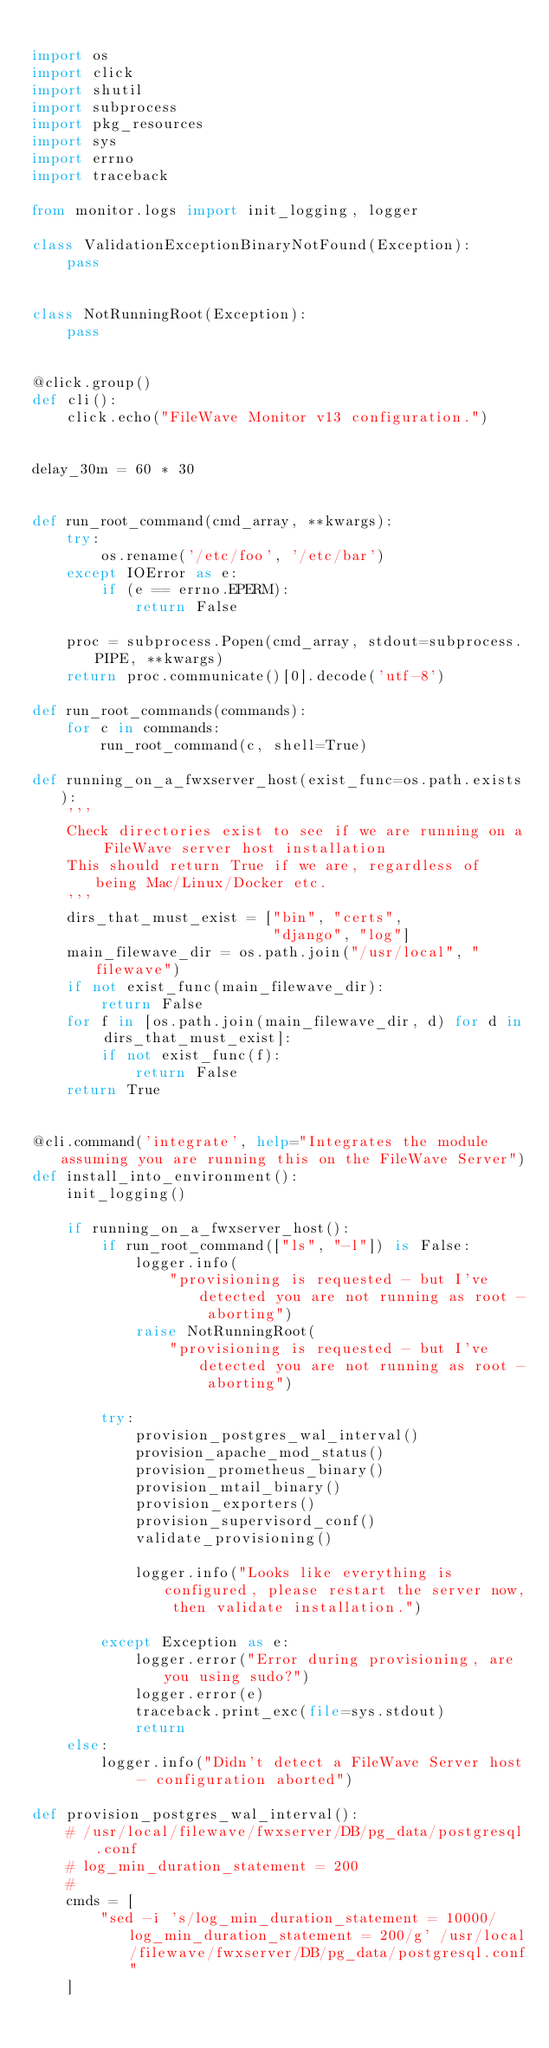<code> <loc_0><loc_0><loc_500><loc_500><_Python_>
import os
import click
import shutil
import subprocess
import pkg_resources
import sys
import errno
import traceback

from monitor.logs import init_logging, logger

class ValidationExceptionBinaryNotFound(Exception):
    pass


class NotRunningRoot(Exception):
    pass


@click.group()
def cli():
    click.echo("FileWave Monitor v13 configuration.")


delay_30m = 60 * 30


def run_root_command(cmd_array, **kwargs):
    try:
        os.rename('/etc/foo', '/etc/bar')
    except IOError as e:
        if (e == errno.EPERM):
            return False

    proc = subprocess.Popen(cmd_array, stdout=subprocess.PIPE, **kwargs)
    return proc.communicate()[0].decode('utf-8')

def run_root_commands(commands):
    for c in commands:
        run_root_command(c, shell=True)

def running_on_a_fwxserver_host(exist_func=os.path.exists):
    '''
    Check directories exist to see if we are running on a FileWave server host installation
    This should return True if we are, regardless of being Mac/Linux/Docker etc.
    '''
    dirs_that_must_exist = ["bin", "certs",
                            "django", "log"]
    main_filewave_dir = os.path.join("/usr/local", "filewave")
    if not exist_func(main_filewave_dir):
        return False
    for f in [os.path.join(main_filewave_dir, d) for d in dirs_that_must_exist]:
        if not exist_func(f):
            return False
    return True


@cli.command('integrate', help="Integrates the module assuming you are running this on the FileWave Server")
def install_into_environment():
    init_logging()

    if running_on_a_fwxserver_host():
        if run_root_command(["ls", "-l"]) is False:
            logger.info(
                "provisioning is requested - but I've detected you are not running as root - aborting")
            raise NotRunningRoot(
                "provisioning is requested - but I've detected you are not running as root - aborting")

        try:
            provision_postgres_wal_interval()
            provision_apache_mod_status()
            provision_prometheus_binary()
            provision_mtail_binary()
            provision_exporters()
            provision_supervisord_conf()
            validate_provisioning()

            logger.info("Looks like everything is configured, please restart the server now, then validate installation.")

        except Exception as e:
            logger.error("Error during provisioning, are you using sudo?")
            logger.error(e)
            traceback.print_exc(file=sys.stdout)
            return
    else:
        logger.info("Didn't detect a FileWave Server host - configuration aborted")

def provision_postgres_wal_interval():
    # /usr/local/filewave/fwxserver/DB/pg_data/postgresql.conf
    # log_min_duration_statement = 200
    #
    cmds = [
        "sed -i 's/log_min_duration_statement = 10000/log_min_duration_statement = 200/g' /usr/local/filewave/fwxserver/DB/pg_data/postgresql.conf"
    ]
</code> 